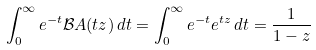Convert formula to latex. <formula><loc_0><loc_0><loc_500><loc_500>\int _ { 0 } ^ { \infty } e ^ { - t } { \mathcal { B } } A ( t z ) \, d t = \int _ { 0 } ^ { \infty } e ^ { - t } e ^ { t z } \, d t = { \frac { 1 } { 1 - z } }</formula> 